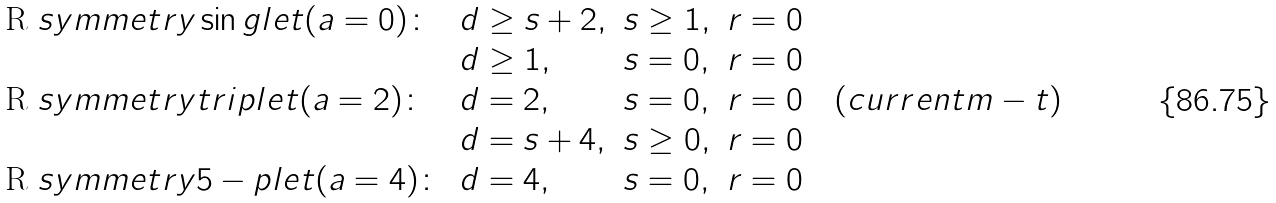<formula> <loc_0><loc_0><loc_500><loc_500>\begin{array} { l l l l } $ R $ s y m m e t r y \sin g l e t ( a = 0 ) \colon & d \geq s + 2 , & s \geq 1 , & r = 0 \\ & d \geq 1 , & s = 0 , & r = 0 \\ $ R $ s y m m e t r y t r i p l e t ( a = 2 ) \colon & d = 2 , & s = 0 , & r = 0 \quad ( c u r r e n t m - t ) \\ & d = s + 4 , & s \geq 0 , & r = 0 \\ $ R $ s y m m e t r y 5 - p l e t ( a = 4 ) \colon & d = 4 , & s = 0 , & r = 0 \end{array}</formula> 